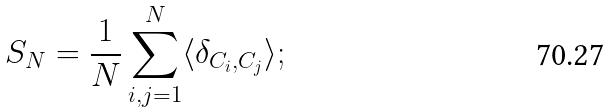Convert formula to latex. <formula><loc_0><loc_0><loc_500><loc_500>S _ { N } = \frac { 1 } { N } \sum _ { i , j = 1 } ^ { N } \langle \delta _ { C _ { i } , C _ { j } } \rangle ;</formula> 